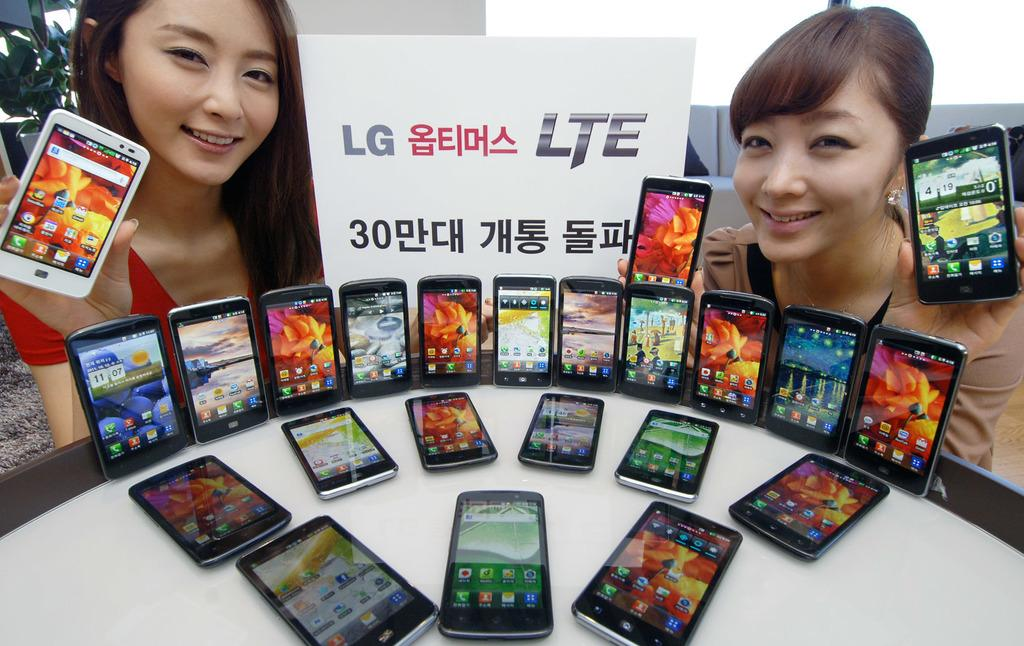<image>
Present a compact description of the photo's key features. Two girls are holding cell phones by a table covered in phones with a sign that says LG LTE. 